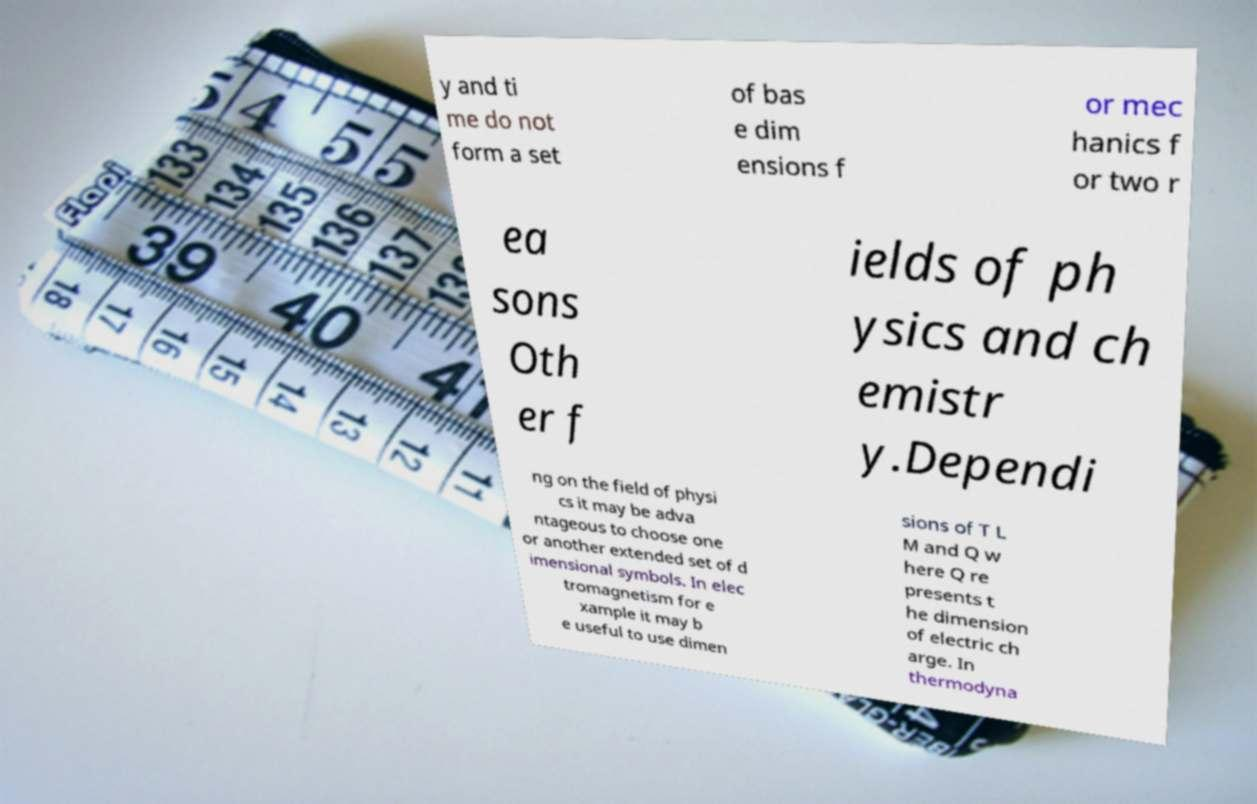Can you accurately transcribe the text from the provided image for me? y and ti me do not form a set of bas e dim ensions f or mec hanics f or two r ea sons Oth er f ields of ph ysics and ch emistr y.Dependi ng on the field of physi cs it may be adva ntageous to choose one or another extended set of d imensional symbols. In elec tromagnetism for e xample it may b e useful to use dimen sions of T L M and Q w here Q re presents t he dimension of electric ch arge. In thermodyna 